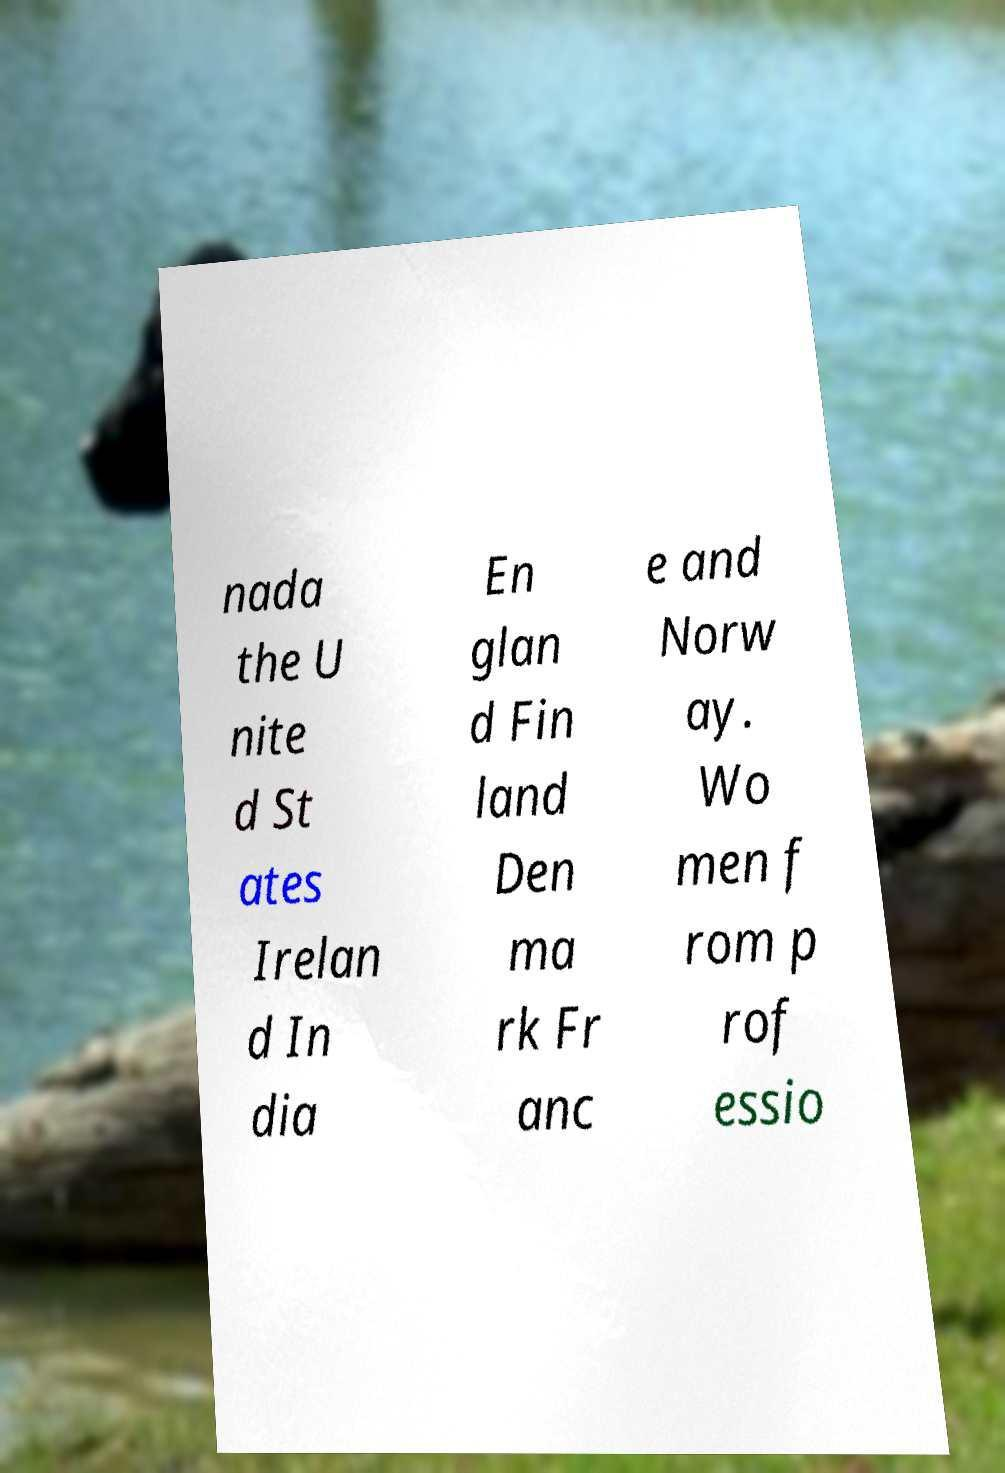Please read and relay the text visible in this image. What does it say? nada the U nite d St ates Irelan d In dia En glan d Fin land Den ma rk Fr anc e and Norw ay. Wo men f rom p rof essio 